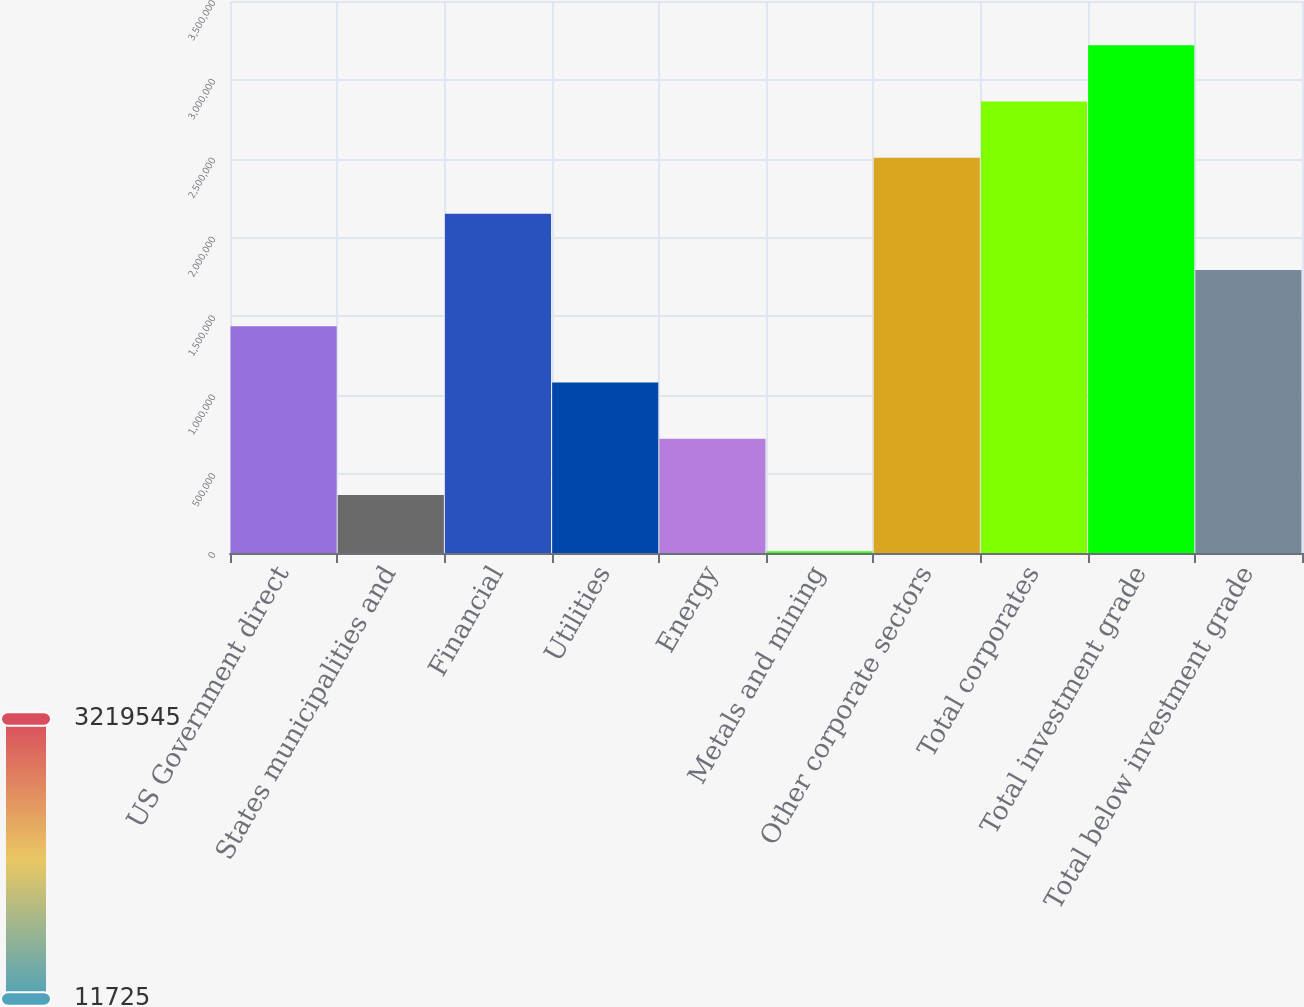Convert chart. <chart><loc_0><loc_0><loc_500><loc_500><bar_chart><fcel>US Government direct<fcel>States municipalities and<fcel>Financial<fcel>Utilities<fcel>Energy<fcel>Metals and mining<fcel>Other corporate sectors<fcel>Total corporates<fcel>Total investment grade<fcel>Total below investment grade<nl><fcel>1.43742e+06<fcel>368149<fcel>2.15027e+06<fcel>1.081e+06<fcel>724574<fcel>11725<fcel>2.5067e+06<fcel>2.86312e+06<fcel>3.21954e+06<fcel>1.79385e+06<nl></chart> 